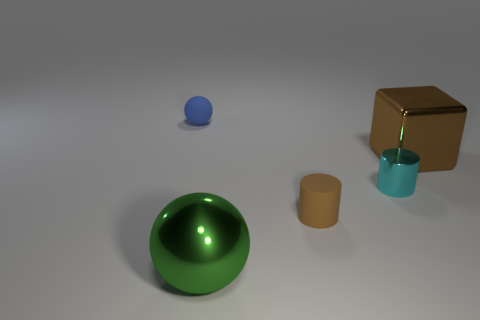Add 1 large cyan metallic balls. How many objects exist? 6 Subtract all cubes. How many objects are left? 4 Add 1 cylinders. How many cylinders are left? 3 Add 1 large gray cylinders. How many large gray cylinders exist? 1 Subtract 1 brown cubes. How many objects are left? 4 Subtract all small blue matte spheres. Subtract all small blue objects. How many objects are left? 3 